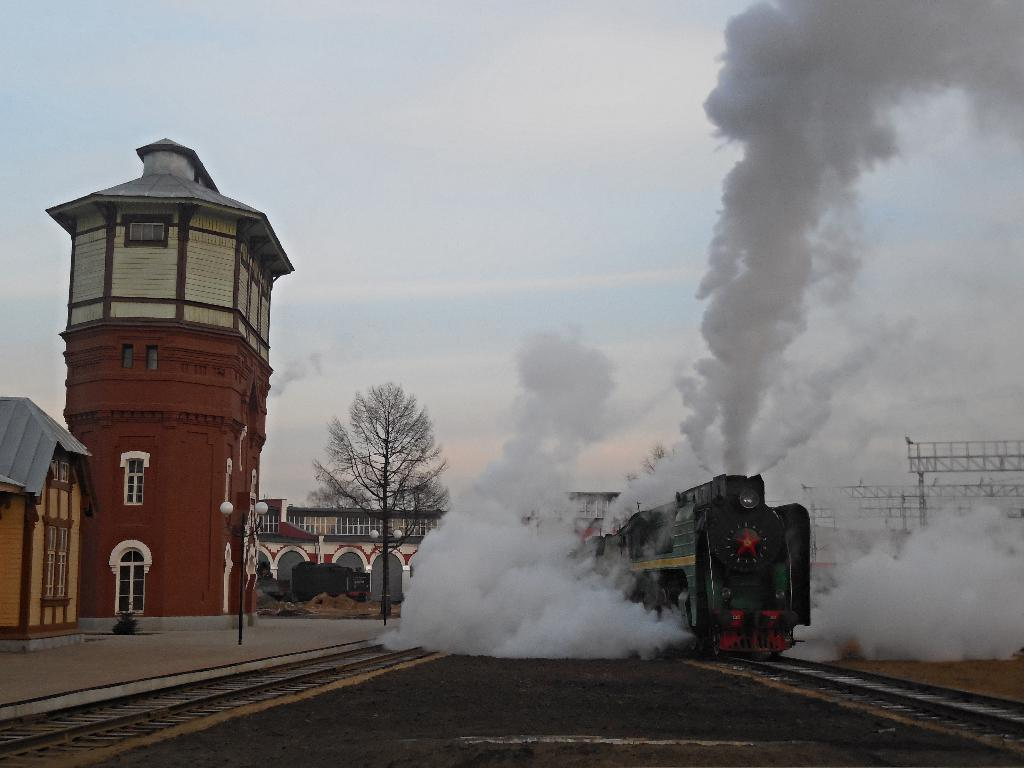What is the main subject of the image? The main subject of the image is a train. What is the train doing in the image? The train is releasing smoke and moving on a track. Where is the track located in the image? The track is on the right side of the image. What can be seen on the left side of the image? There are buildings on the left side of the image, and a tree is in front of the buildings. What is visible in the sky in the image? The sky is visible in the image, and clouds are present. Can you tell me how many times the girl sneezes in the image? There is no girl present in the image, and therefore no sneezing can be observed. Is there a river flowing near the train in the image? There is no river visible in the image; it features a train, track, buildings, a tree, and the sky. 